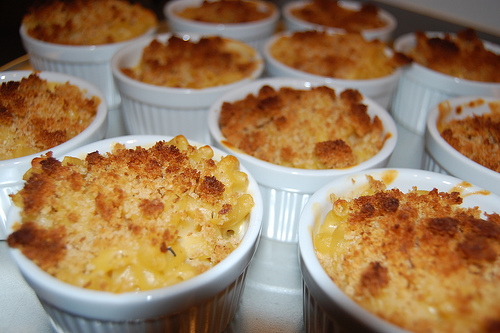<image>
Is there a spoon to the right of the ring? No. The spoon is not to the right of the ring. The horizontal positioning shows a different relationship. Is there a chicken soup in the bucket? Yes. The chicken soup is contained within or inside the bucket, showing a containment relationship. Is there a cake in the cup? Yes. The cake is contained within or inside the cup, showing a containment relationship. Is there a pudding in the cup? Yes. The pudding is contained within or inside the cup, showing a containment relationship. 